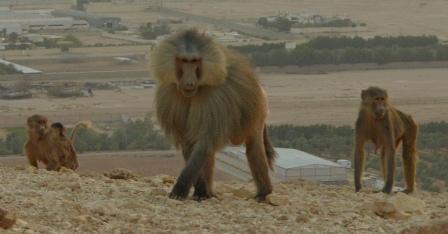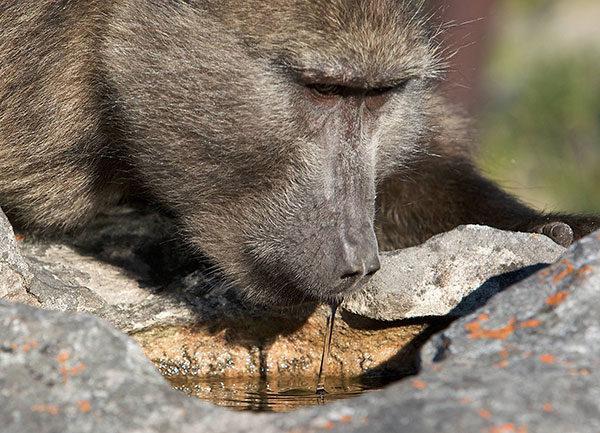The first image is the image on the left, the second image is the image on the right. Examine the images to the left and right. Is the description "There are 2 adult apes in a grassy environment." accurate? Answer yes or no. No. The first image is the image on the left, the second image is the image on the right. Given the left and right images, does the statement "An image shows two rear-facing baboons." hold true? Answer yes or no. No. 